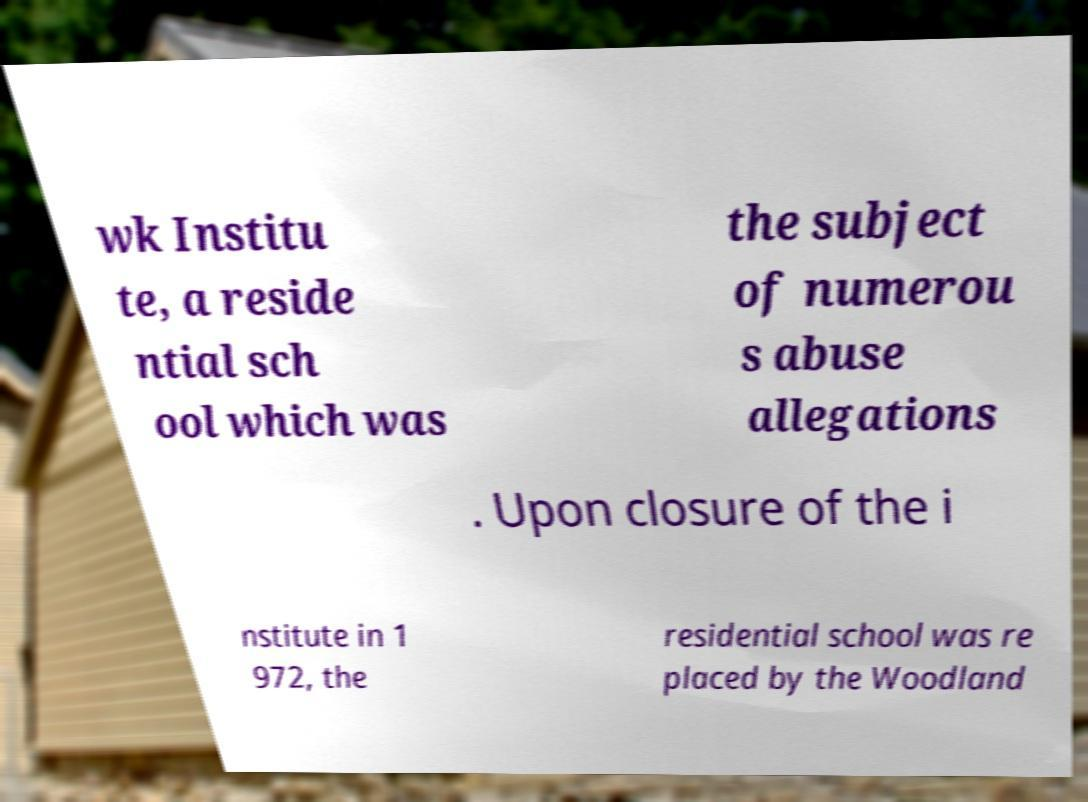Could you extract and type out the text from this image? wk Institu te, a reside ntial sch ool which was the subject of numerou s abuse allegations . Upon closure of the i nstitute in 1 972, the residential school was re placed by the Woodland 